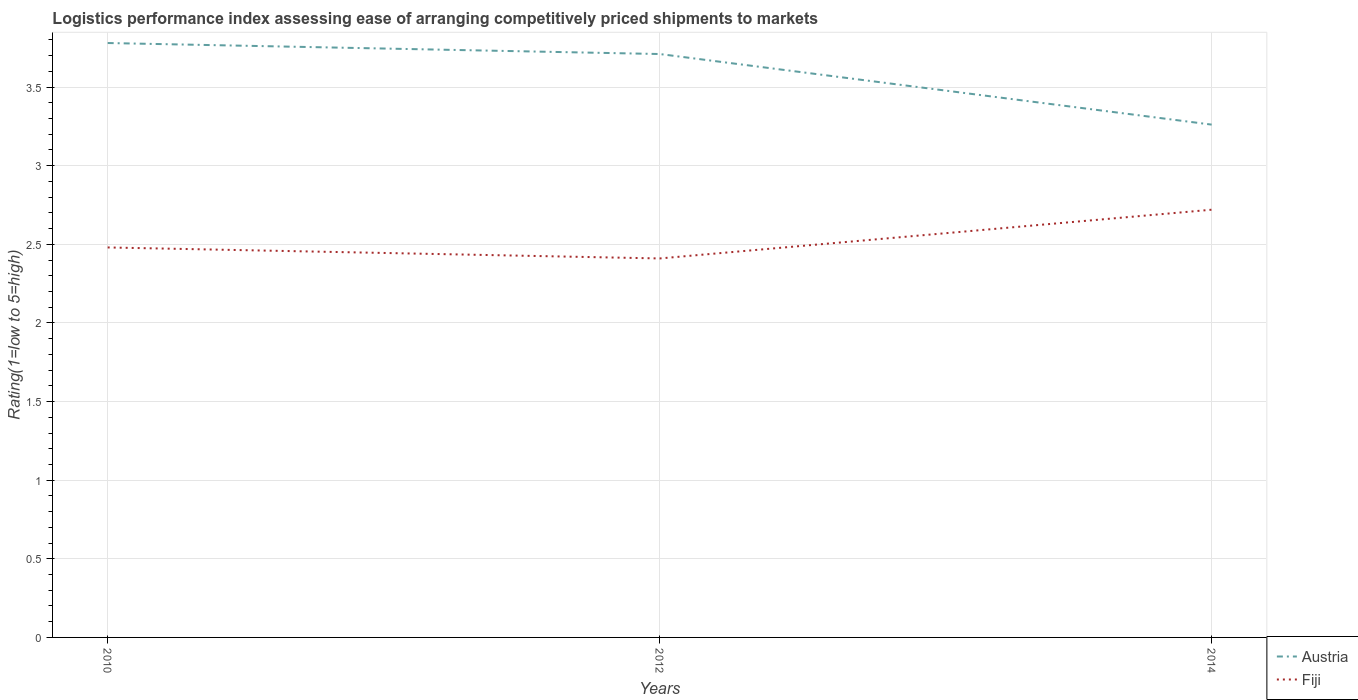How many different coloured lines are there?
Provide a short and direct response. 2. Is the number of lines equal to the number of legend labels?
Make the answer very short. Yes. Across all years, what is the maximum Logistic performance index in Fiji?
Keep it short and to the point. 2.41. In which year was the Logistic performance index in Fiji maximum?
Provide a short and direct response. 2012. What is the total Logistic performance index in Austria in the graph?
Your answer should be compact. 0.45. What is the difference between the highest and the second highest Logistic performance index in Fiji?
Make the answer very short. 0.31. Is the Logistic performance index in Austria strictly greater than the Logistic performance index in Fiji over the years?
Offer a terse response. No. How many lines are there?
Ensure brevity in your answer.  2. How many years are there in the graph?
Provide a succinct answer. 3. What is the difference between two consecutive major ticks on the Y-axis?
Ensure brevity in your answer.  0.5. Are the values on the major ticks of Y-axis written in scientific E-notation?
Your response must be concise. No. Does the graph contain any zero values?
Provide a short and direct response. No. Does the graph contain grids?
Provide a short and direct response. Yes. How many legend labels are there?
Keep it short and to the point. 2. How are the legend labels stacked?
Offer a terse response. Vertical. What is the title of the graph?
Keep it short and to the point. Logistics performance index assessing ease of arranging competitively priced shipments to markets. Does "World" appear as one of the legend labels in the graph?
Make the answer very short. No. What is the label or title of the X-axis?
Offer a very short reply. Years. What is the label or title of the Y-axis?
Your response must be concise. Rating(1=low to 5=high). What is the Rating(1=low to 5=high) of Austria in 2010?
Make the answer very short. 3.78. What is the Rating(1=low to 5=high) in Fiji in 2010?
Provide a short and direct response. 2.48. What is the Rating(1=low to 5=high) of Austria in 2012?
Offer a very short reply. 3.71. What is the Rating(1=low to 5=high) in Fiji in 2012?
Offer a terse response. 2.41. What is the Rating(1=low to 5=high) in Austria in 2014?
Provide a succinct answer. 3.26. What is the Rating(1=low to 5=high) in Fiji in 2014?
Ensure brevity in your answer.  2.72. Across all years, what is the maximum Rating(1=low to 5=high) of Austria?
Your answer should be compact. 3.78. Across all years, what is the maximum Rating(1=low to 5=high) in Fiji?
Offer a terse response. 2.72. Across all years, what is the minimum Rating(1=low to 5=high) in Austria?
Give a very brief answer. 3.26. Across all years, what is the minimum Rating(1=low to 5=high) of Fiji?
Provide a short and direct response. 2.41. What is the total Rating(1=low to 5=high) in Austria in the graph?
Provide a short and direct response. 10.75. What is the total Rating(1=low to 5=high) in Fiji in the graph?
Ensure brevity in your answer.  7.61. What is the difference between the Rating(1=low to 5=high) in Austria in 2010 and that in 2012?
Offer a very short reply. 0.07. What is the difference between the Rating(1=low to 5=high) in Fiji in 2010 and that in 2012?
Make the answer very short. 0.07. What is the difference between the Rating(1=low to 5=high) in Austria in 2010 and that in 2014?
Keep it short and to the point. 0.52. What is the difference between the Rating(1=low to 5=high) of Fiji in 2010 and that in 2014?
Give a very brief answer. -0.24. What is the difference between the Rating(1=low to 5=high) in Austria in 2012 and that in 2014?
Keep it short and to the point. 0.45. What is the difference between the Rating(1=low to 5=high) of Fiji in 2012 and that in 2014?
Your response must be concise. -0.31. What is the difference between the Rating(1=low to 5=high) of Austria in 2010 and the Rating(1=low to 5=high) of Fiji in 2012?
Your answer should be very brief. 1.37. What is the difference between the Rating(1=low to 5=high) in Austria in 2010 and the Rating(1=low to 5=high) in Fiji in 2014?
Provide a short and direct response. 1.06. What is the average Rating(1=low to 5=high) of Austria per year?
Your answer should be compact. 3.58. What is the average Rating(1=low to 5=high) of Fiji per year?
Offer a very short reply. 2.54. In the year 2012, what is the difference between the Rating(1=low to 5=high) in Austria and Rating(1=low to 5=high) in Fiji?
Give a very brief answer. 1.3. In the year 2014, what is the difference between the Rating(1=low to 5=high) of Austria and Rating(1=low to 5=high) of Fiji?
Make the answer very short. 0.54. What is the ratio of the Rating(1=low to 5=high) of Austria in 2010 to that in 2012?
Provide a succinct answer. 1.02. What is the ratio of the Rating(1=low to 5=high) in Fiji in 2010 to that in 2012?
Your response must be concise. 1.03. What is the ratio of the Rating(1=low to 5=high) of Austria in 2010 to that in 2014?
Make the answer very short. 1.16. What is the ratio of the Rating(1=low to 5=high) of Fiji in 2010 to that in 2014?
Provide a short and direct response. 0.91. What is the ratio of the Rating(1=low to 5=high) of Austria in 2012 to that in 2014?
Keep it short and to the point. 1.14. What is the ratio of the Rating(1=low to 5=high) in Fiji in 2012 to that in 2014?
Ensure brevity in your answer.  0.89. What is the difference between the highest and the second highest Rating(1=low to 5=high) in Austria?
Your answer should be very brief. 0.07. What is the difference between the highest and the second highest Rating(1=low to 5=high) of Fiji?
Make the answer very short. 0.24. What is the difference between the highest and the lowest Rating(1=low to 5=high) of Austria?
Your response must be concise. 0.52. What is the difference between the highest and the lowest Rating(1=low to 5=high) in Fiji?
Your answer should be very brief. 0.31. 